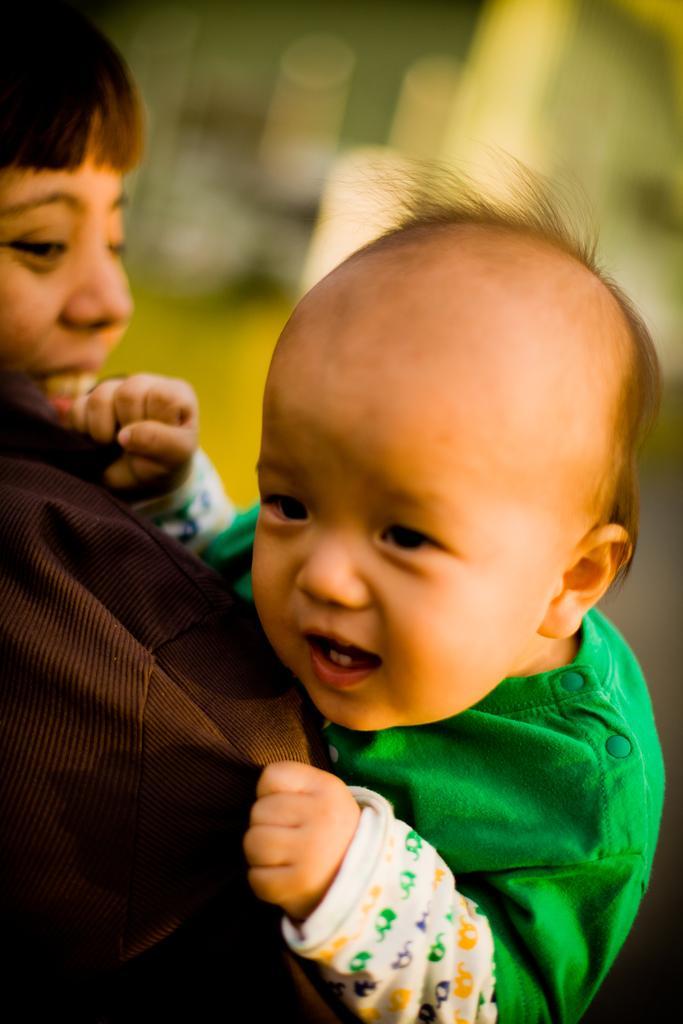Can you describe this image briefly? In the foreground of this image, there is a woman wearing brown coat is carrying a kid wearing green dress and the background image is blurred. 